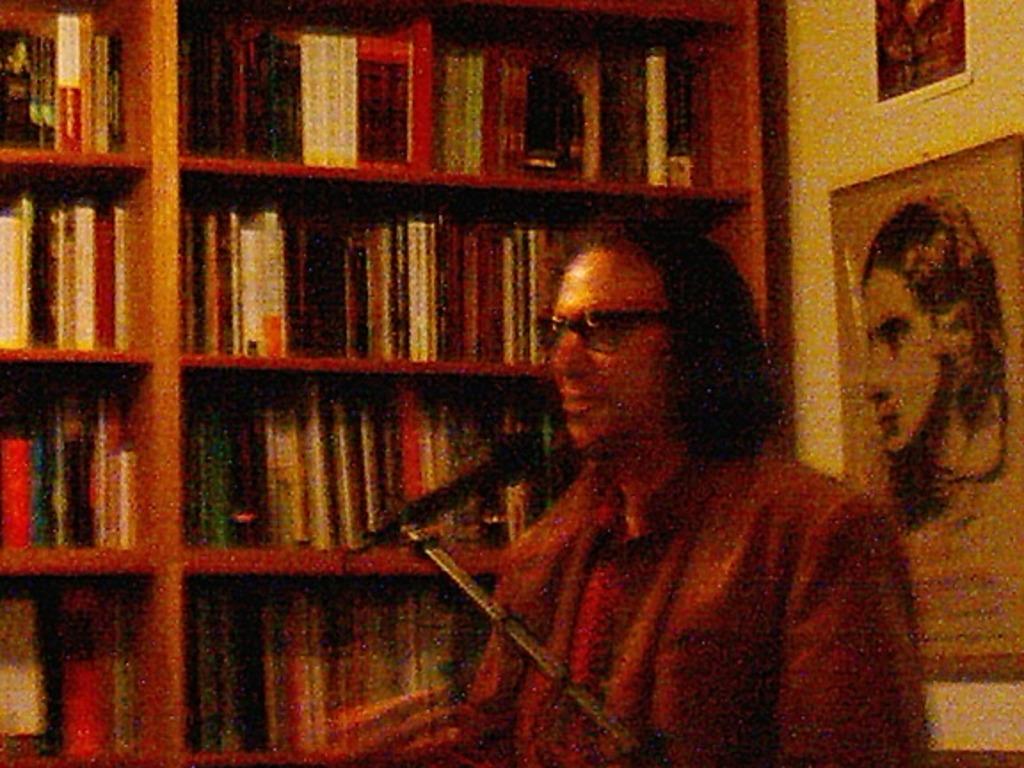What is in front of the man?
Give a very brief answer. Answering does not require reading text in the image. 